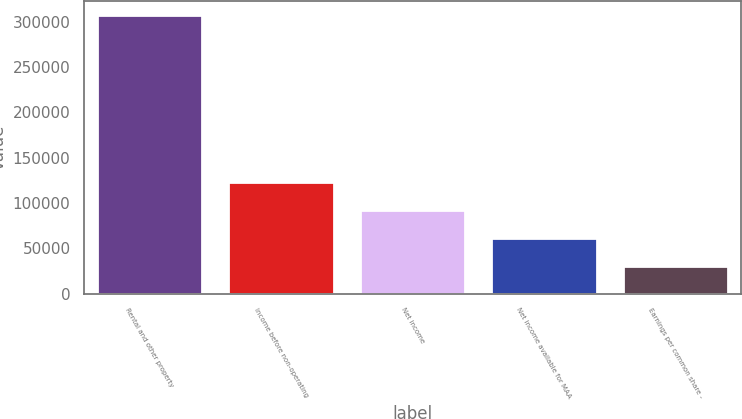Convert chart. <chart><loc_0><loc_0><loc_500><loc_500><bar_chart><fcel>Rental and other property<fcel>Income before non-operating<fcel>Net income<fcel>Net income available for MAA<fcel>Earnings per common share -<nl><fcel>307198<fcel>122879<fcel>92159.7<fcel>61440<fcel>30720.2<nl></chart> 